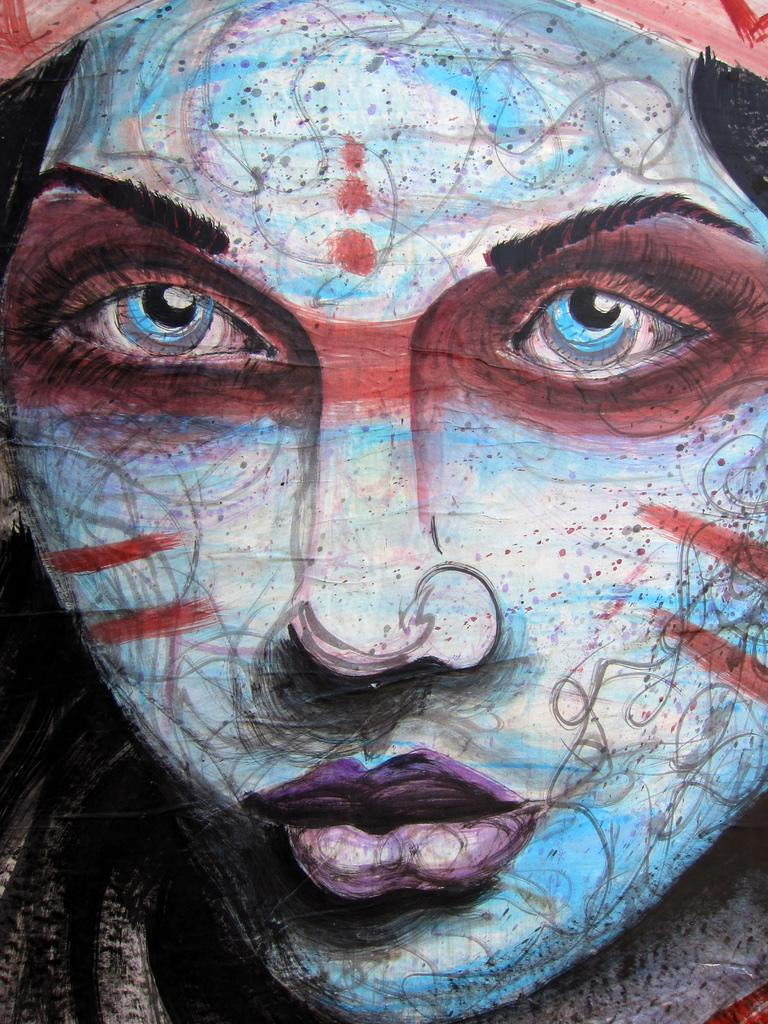What type of artwork is depicted in the image? The image appears to be a painting. What is the main subject of the painting? There is a picture of a person's face in the painting. What facial features can be seen in the painting? The person's eyes, nose, and mouth are visible in the painting. What type of knee can be seen in the painting? There is no knee visible in the painting; it features a person's face. How does the person in the painting express disgust? The painting does not depict any expressions of disgust; it only shows the person's face with visible eyes, nose, and mouth. 